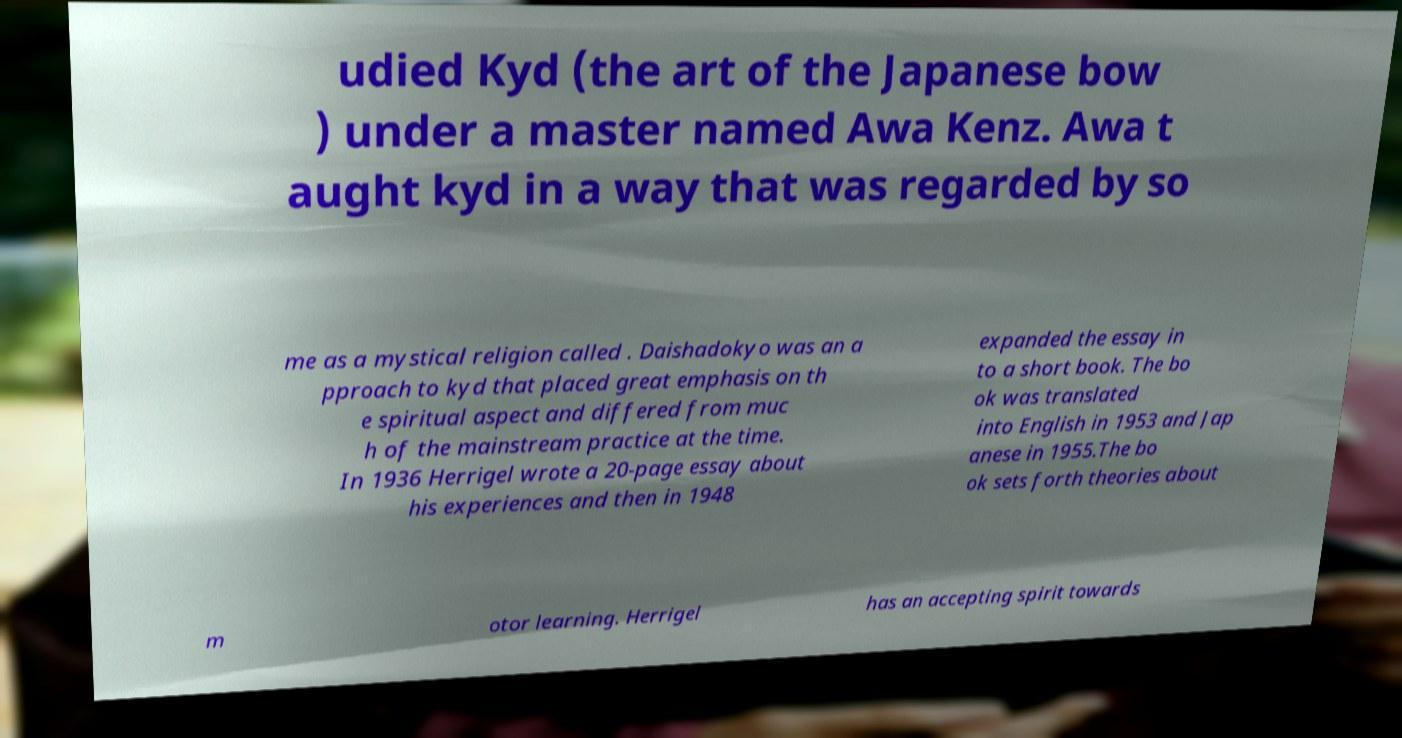What messages or text are displayed in this image? I need them in a readable, typed format. udied Kyd (the art of the Japanese bow ) under a master named Awa Kenz. Awa t aught kyd in a way that was regarded by so me as a mystical religion called . Daishadokyo was an a pproach to kyd that placed great emphasis on th e spiritual aspect and differed from muc h of the mainstream practice at the time. In 1936 Herrigel wrote a 20-page essay about his experiences and then in 1948 expanded the essay in to a short book. The bo ok was translated into English in 1953 and Jap anese in 1955.The bo ok sets forth theories about m otor learning. Herrigel has an accepting spirit towards 